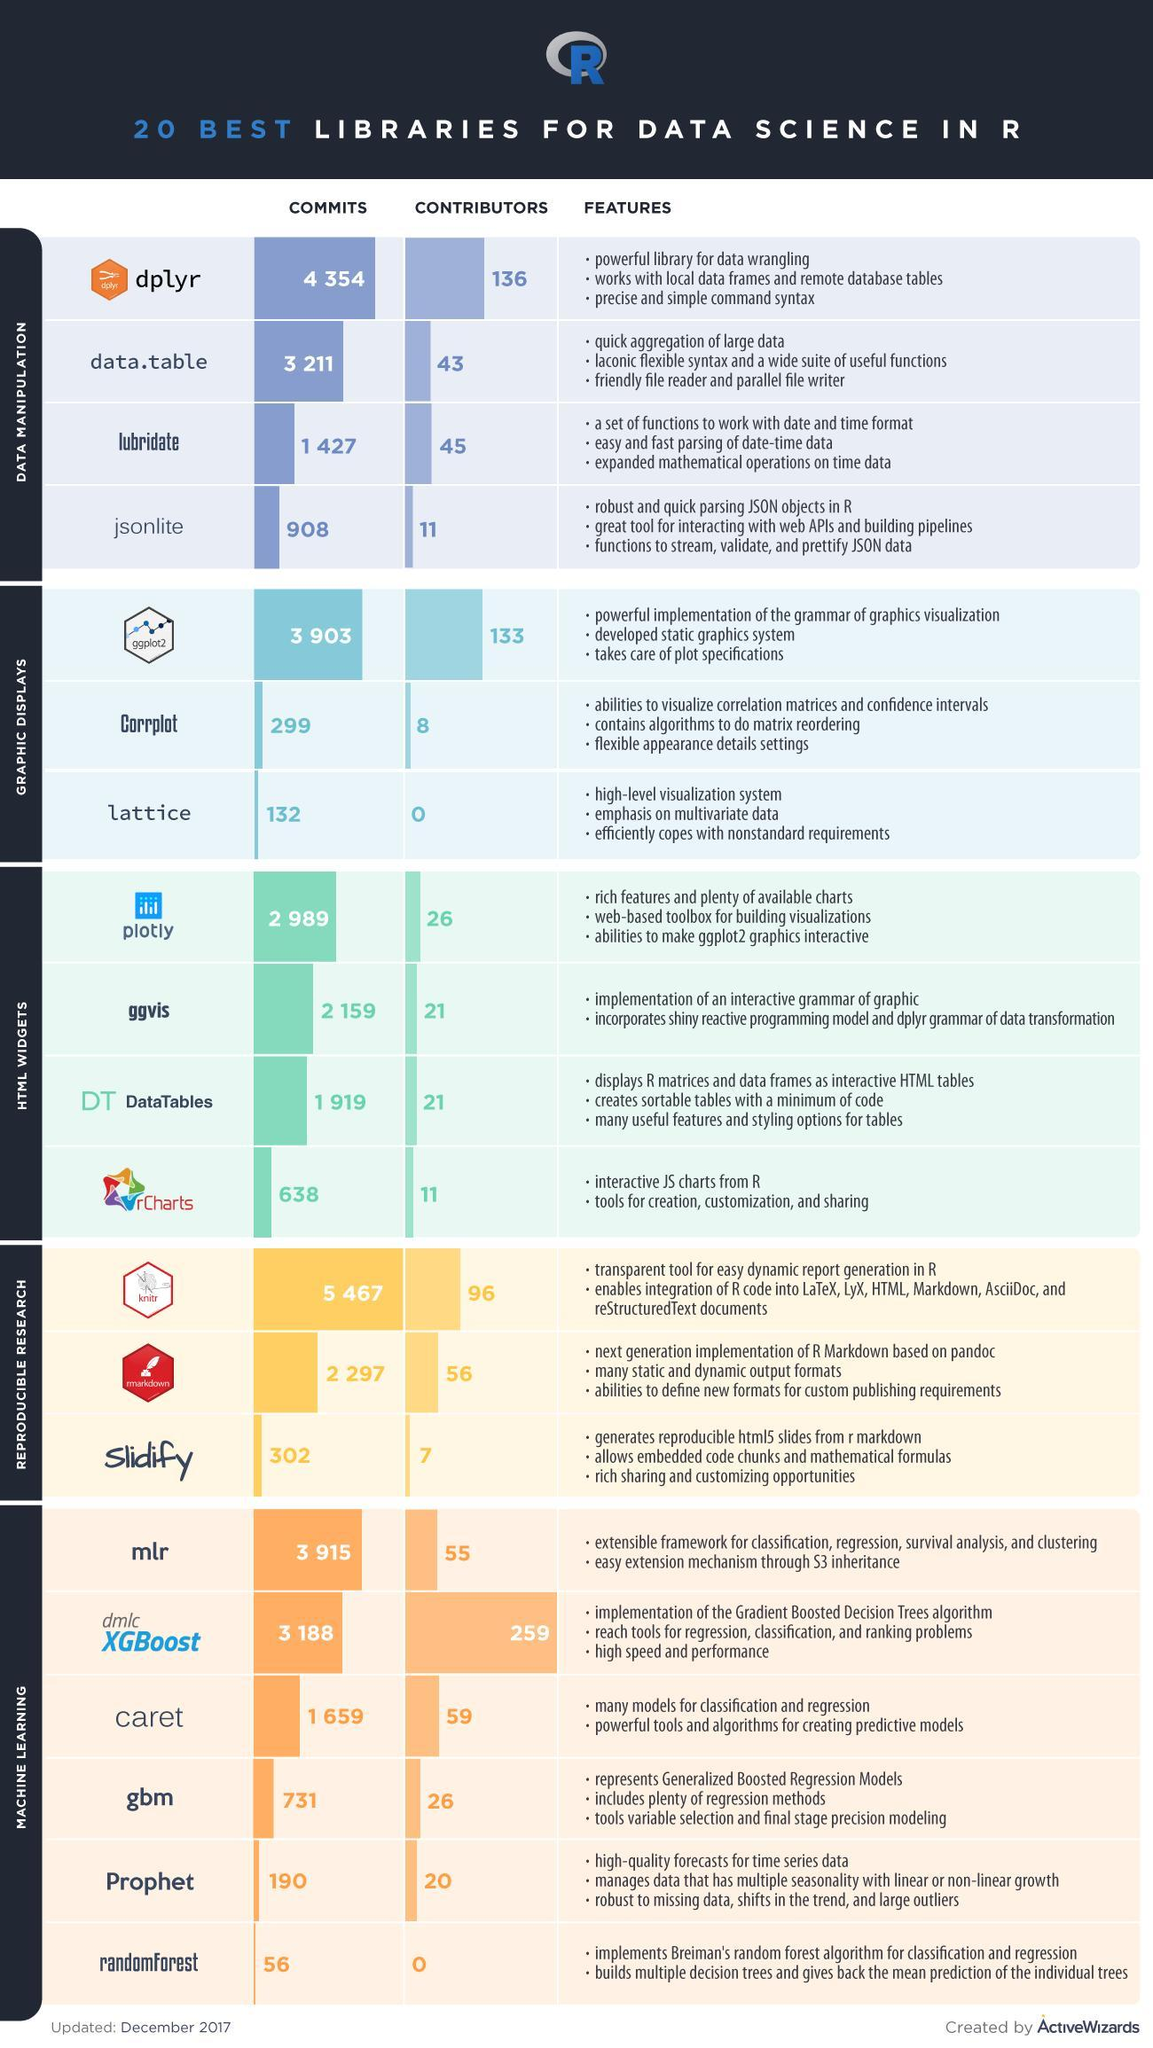How many libraries for the graphic displays?
Answer the question with a short phrase. 3 How many libraries for Machine learning? 6 How many libraries for Html widgets? 4 What is the number of contributors of dplyr and jsonlite, taken together? 147 How many points are under the heading features of "dplyr"? 3 